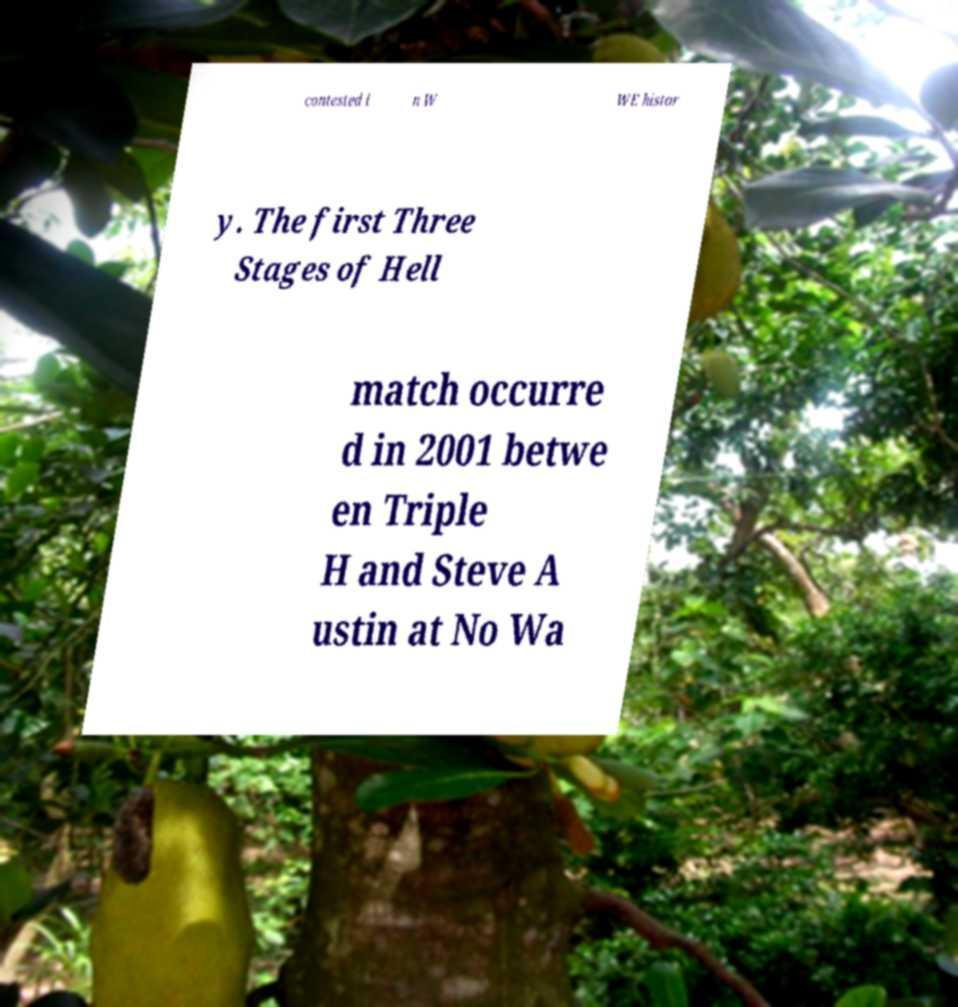What messages or text are displayed in this image? I need them in a readable, typed format. contested i n W WE histor y. The first Three Stages of Hell match occurre d in 2001 betwe en Triple H and Steve A ustin at No Wa 